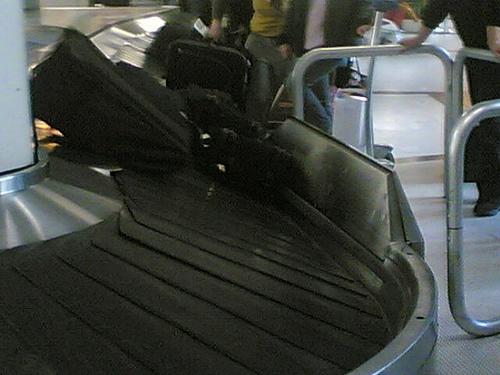Describe the objects in this image and their specific colors. I can see suitcase in darkgray, black, gray, and darkgreen tones, people in darkgray, black, and gray tones, people in darkgray, black, darkgreen, and gray tones, handbag in darkgray, black, gray, olive, and darkgreen tones, and suitcase in darkgray, black, and gray tones in this image. 